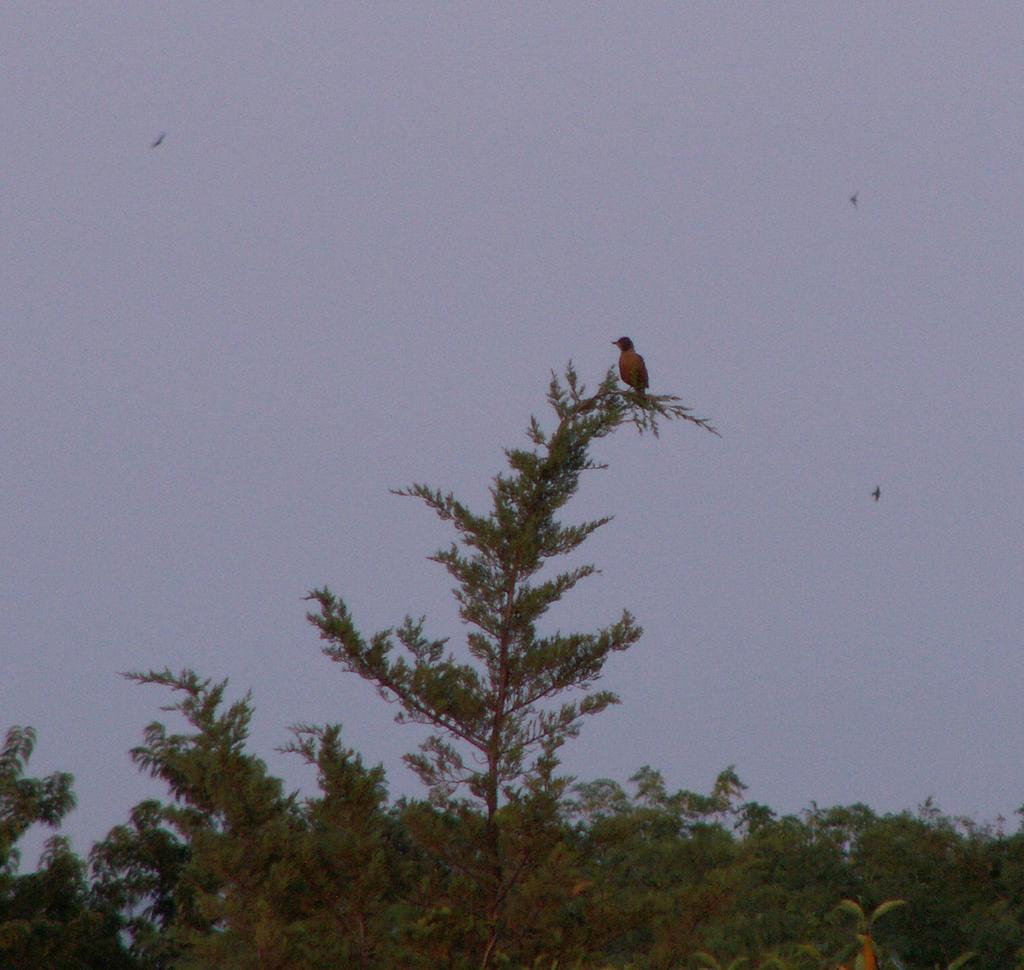What type of vegetation is present at the bottom of the image? There are trees at the bottom of the image. What can be seen on one of the trees in the image? There is a bird on a tree in the middle of the image. What part of the natural environment is visible in the background of the image? The sky is visible in the background of the image. What type of tools does the carpenter use in the image? There is no carpenter present in the image. How many sticks are visible in the image? There are no sticks visible in the image. 